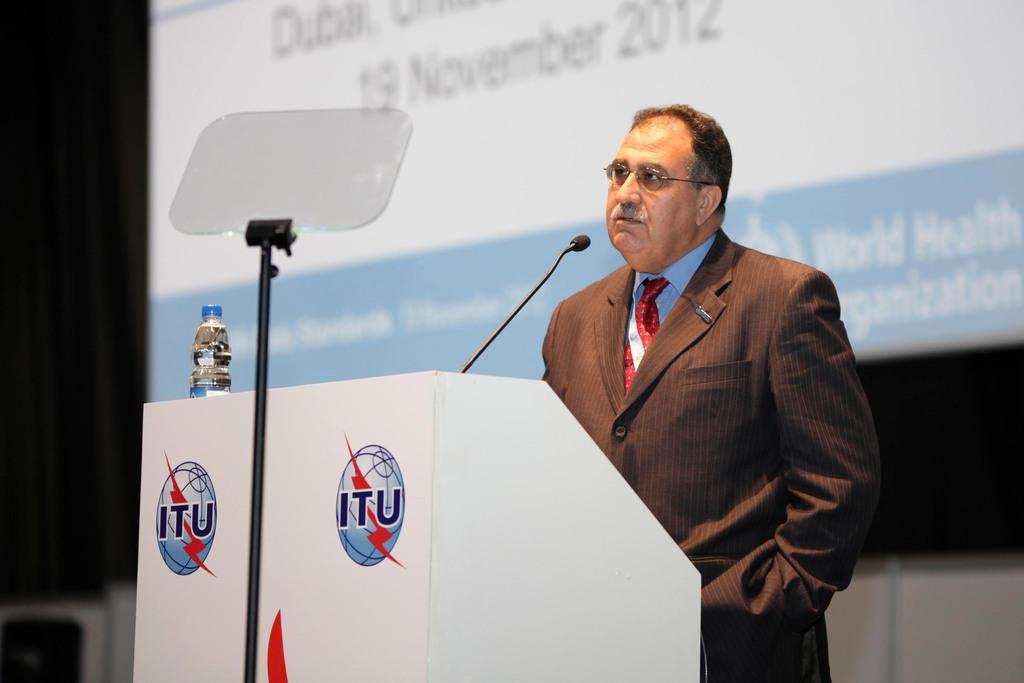What is the main subject of the image? There is a person standing on a stage in the image. What is the person standing in front of? The person is in front of a table. What object is used for amplifying the person's voice? A microphone (mike) is present in the image. What can be seen in the background of the image? There is a screen in the background of the image, and the background appears to be dark. Where might this image have been taken? The image may have been taken in a hall. How many keys can be seen hanging from the person's belt in the image? There are no keys visible in the image; the focus is on the person standing on the stage, the table, microphone, screen, and the possible location of the image. 